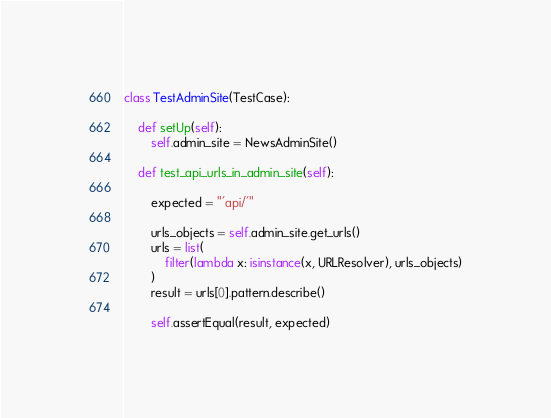<code> <loc_0><loc_0><loc_500><loc_500><_Python_>

class TestAdminSite(TestCase):

    def setUp(self):
        self.admin_site = NewsAdminSite()
        
    def test_api_urls_in_admin_site(self):

        expected = "'api/'"

        urls_objects = self.admin_site.get_urls()
        urls = list(
            filter(lambda x: isinstance(x, URLResolver), urls_objects)
        )
        result = urls[0].pattern.describe()

        self.assertEqual(result, expected)
</code> 